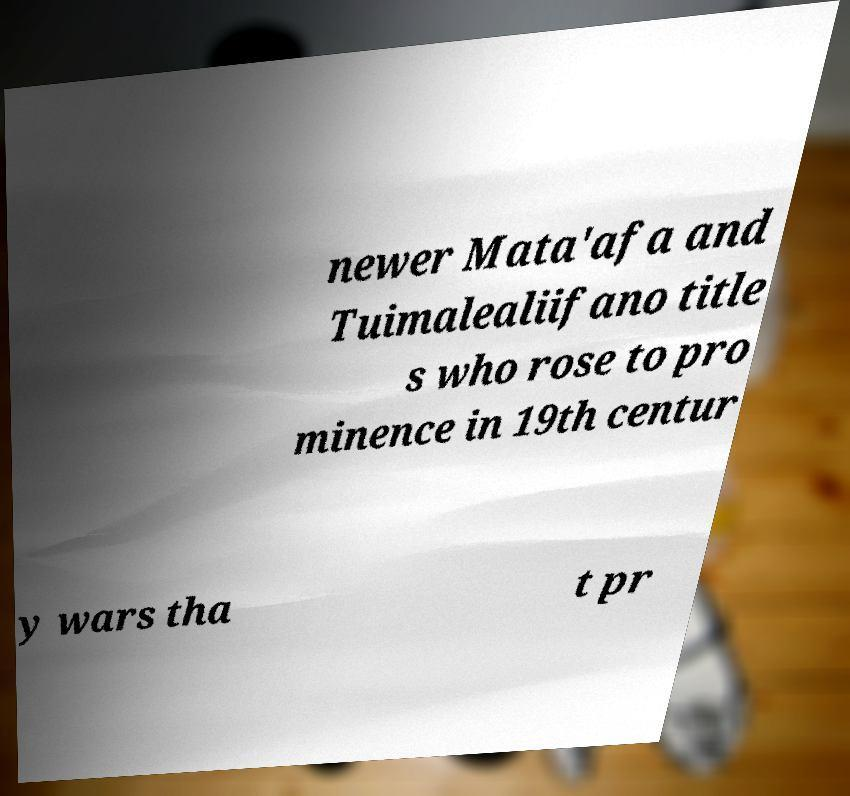Could you assist in decoding the text presented in this image and type it out clearly? newer Mata'afa and Tuimalealiifano title s who rose to pro minence in 19th centur y wars tha t pr 